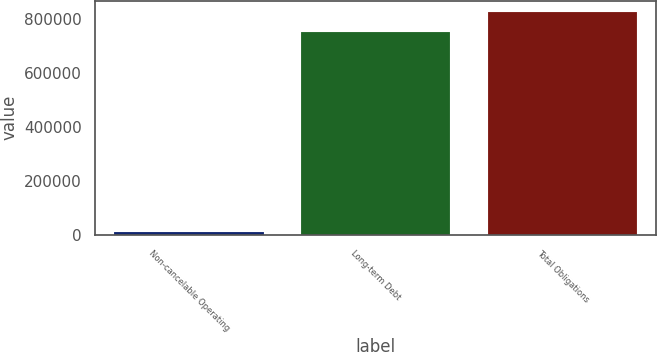<chart> <loc_0><loc_0><loc_500><loc_500><bar_chart><fcel>Non-cancelable Operating<fcel>Long-term Debt<fcel>Total Obligations<nl><fcel>10938<fcel>752330<fcel>827563<nl></chart> 